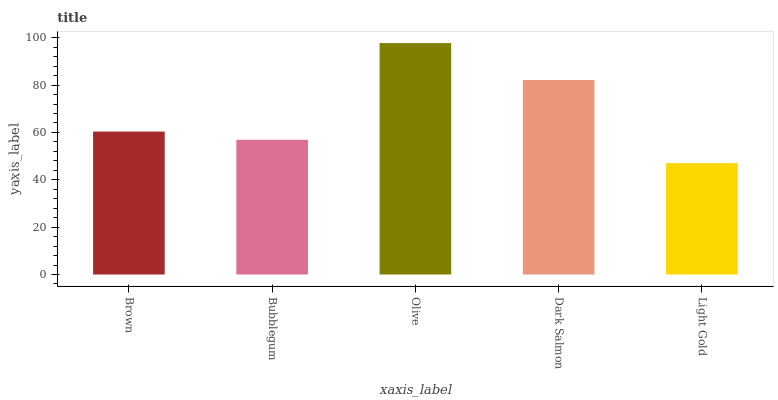Is Light Gold the minimum?
Answer yes or no. Yes. Is Olive the maximum?
Answer yes or no. Yes. Is Bubblegum the minimum?
Answer yes or no. No. Is Bubblegum the maximum?
Answer yes or no. No. Is Brown greater than Bubblegum?
Answer yes or no. Yes. Is Bubblegum less than Brown?
Answer yes or no. Yes. Is Bubblegum greater than Brown?
Answer yes or no. No. Is Brown less than Bubblegum?
Answer yes or no. No. Is Brown the high median?
Answer yes or no. Yes. Is Brown the low median?
Answer yes or no. Yes. Is Light Gold the high median?
Answer yes or no. No. Is Light Gold the low median?
Answer yes or no. No. 